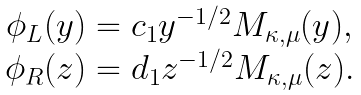<formula> <loc_0><loc_0><loc_500><loc_500>\begin{array} { c c } \phi _ { L } ( y ) = c _ { 1 } y ^ { - 1 / 2 } M _ { \kappa , \mu } ( y ) , & \\ \phi _ { R } ( z ) = d _ { 1 } z ^ { - 1 / 2 } M _ { \kappa , \mu } ( z ) . & \end{array}</formula> 